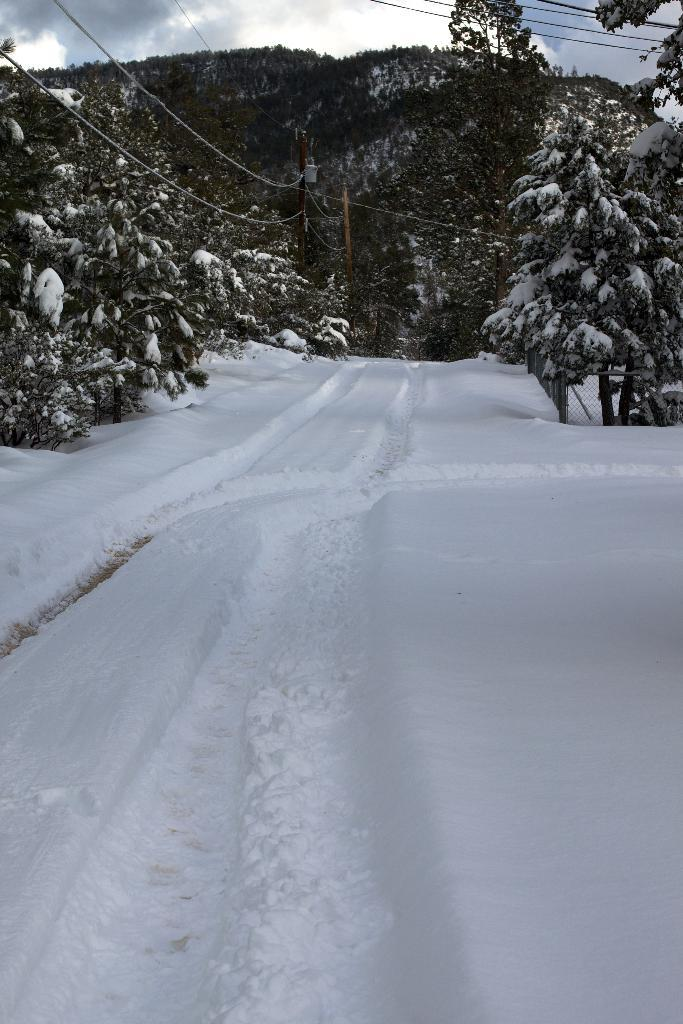What type of weather is depicted in the image? There is snow on the land in the image, indicating a winter scene. What can be seen on the left side of the image? There are wires on the left side of the image. What is visible in the background of the image? There are trees, hills, and clouds in the sky in the background of the image. How many events are happening simultaneously in the image? There is no indication of any events happening in the image; it is a static scene. Is the image set during the nighttime? The image does not provide any information about the time of day, but the presence of snow suggests it could be daytime. 